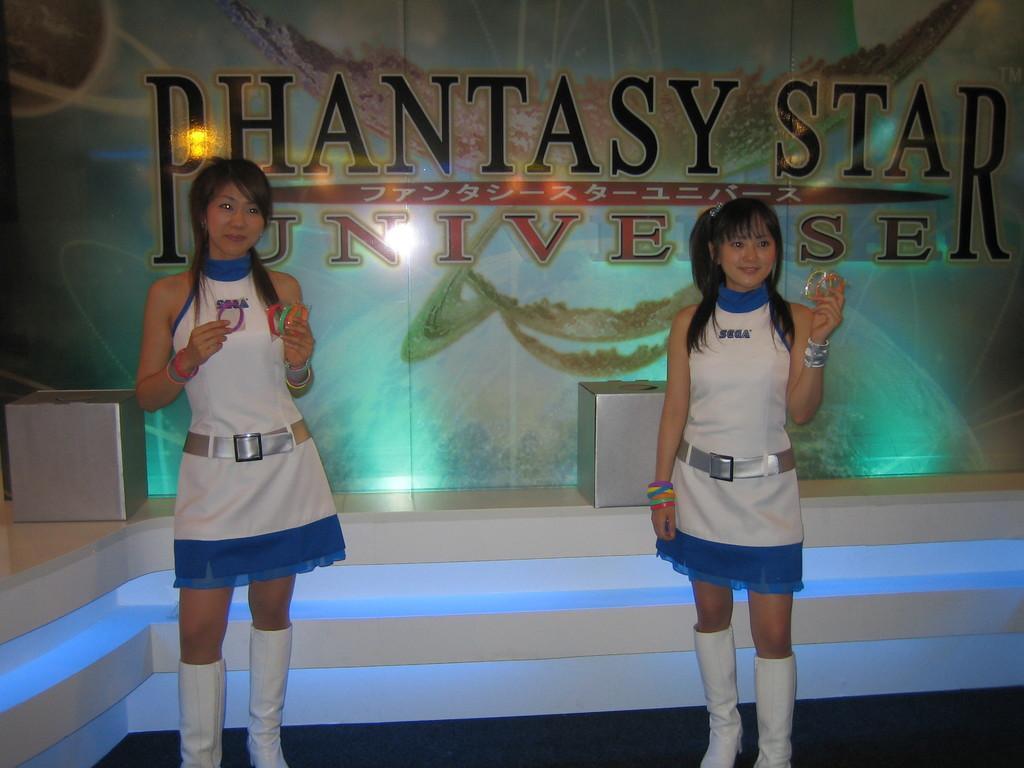Can you describe this image briefly? In the picture I can see two women are standing and smiling. These women are holding some objects in hands. In the background I can see a wall which has something written on it and some other objects on the floor. 